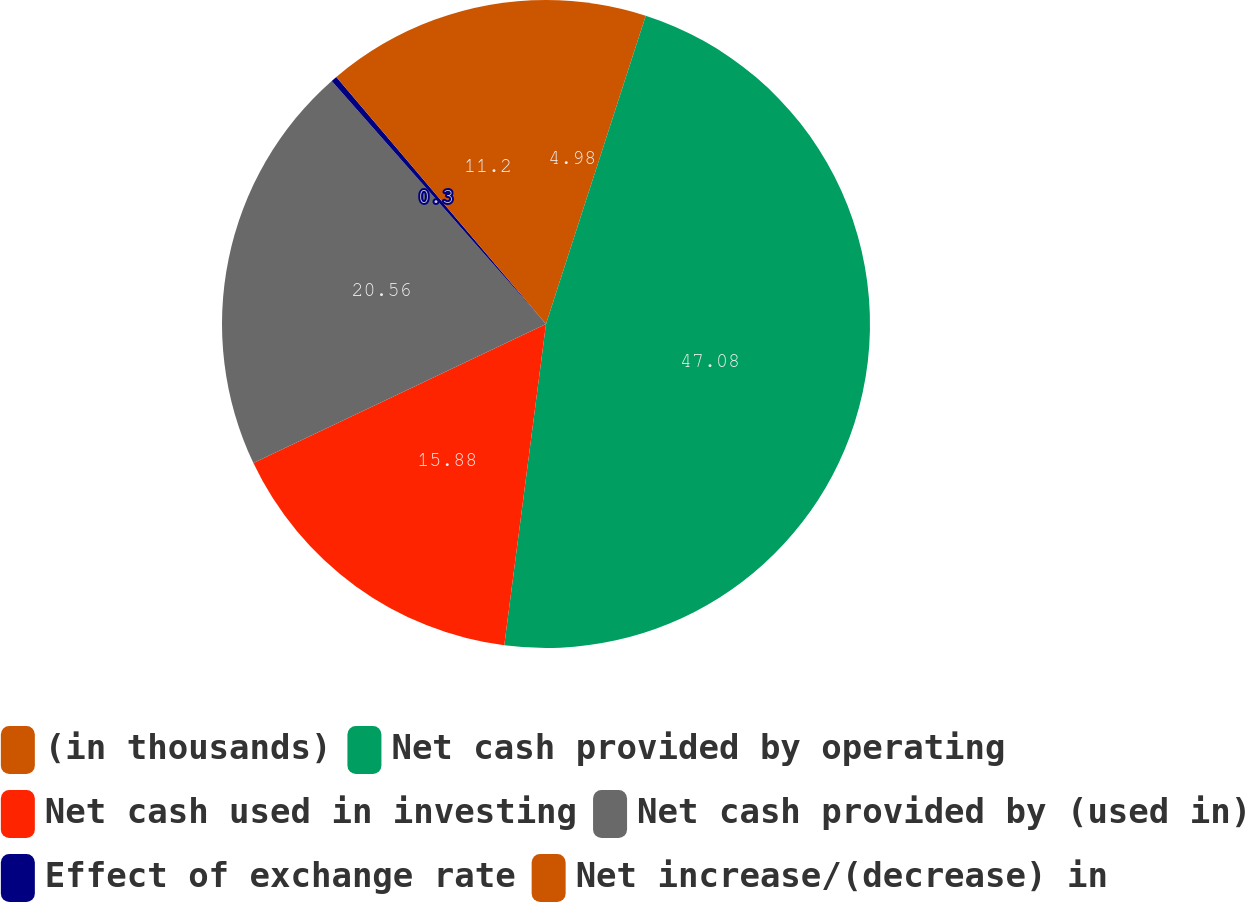Convert chart. <chart><loc_0><loc_0><loc_500><loc_500><pie_chart><fcel>(in thousands)<fcel>Net cash provided by operating<fcel>Net cash used in investing<fcel>Net cash provided by (used in)<fcel>Effect of exchange rate<fcel>Net increase/(decrease) in<nl><fcel>4.98%<fcel>47.07%<fcel>15.88%<fcel>20.56%<fcel>0.3%<fcel>11.2%<nl></chart> 